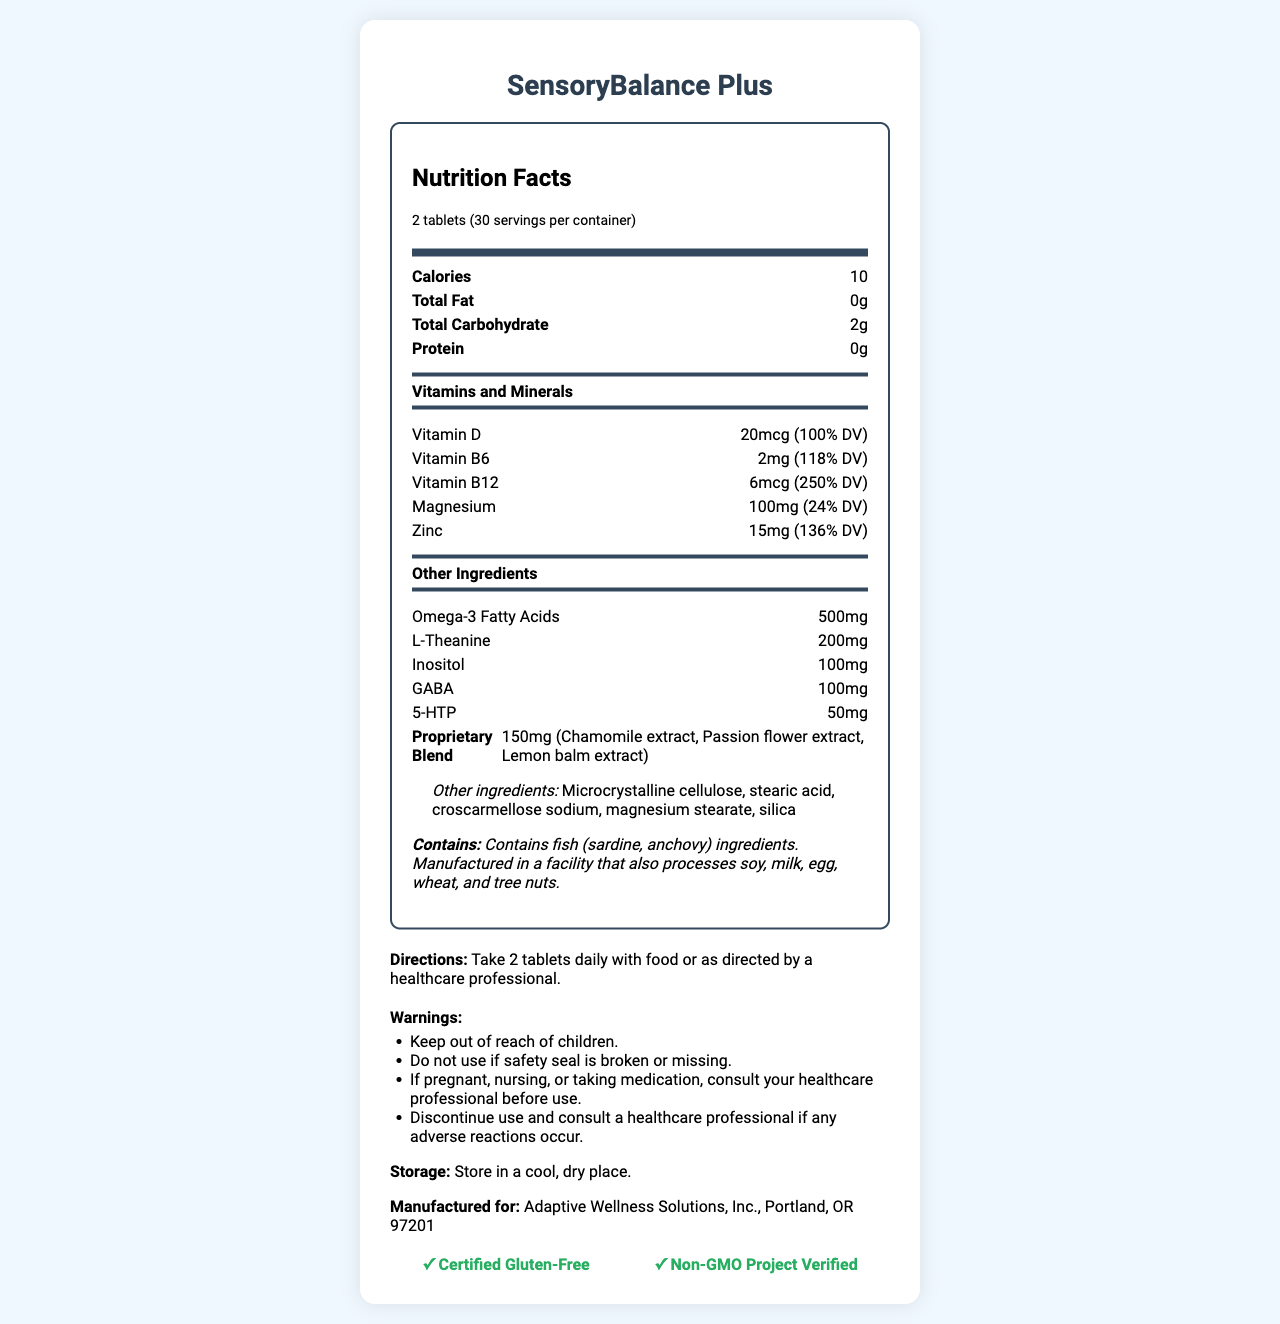what is the serving size for SensoryBalance Plus? The label clearly states that the serving size is 2 tablets.
Answer: 2 tablets how many servings are in one container? The document indicates that there are 30 servings per container.
Answer: 30 how many calories are in one serving? The section titled "Nutrition Facts" lists that each serving contains 10 calories.
Answer: 10 what percentage of the daily value (% DV) of Vitamin D does one serving provide? The nutrition label notes that there is 20mcg of Vitamin D, which is 100% of the daily value.
Answer: 100% what is the total amount of magnesium in one serving? In the "Vitamins and Minerals" section, it lists magnesium at 100mg per serving.
Answer: 100mg which ingredient listed under other ingredients might be of concern for individuals with fish allergies? A. Microcrystalline cellulose B. Stearic acid C. Croscarmellose sodium D. Omega-3 Fatty Acids The allergen information mentions that the product contains fish (sardine, anchovy) ingredients, which are associated with omega-3 fatty acids.
Answer: D. Omega-3 Fatty Acids which of the following vitamins is present in the highest percentage of the daily value? I. Vitamin D II. Vitamin B6 III. Vitamin B12 IV. Magnesium Vitamin B12 is listed at 250% DV, which is higher than the other vitamins mentioned.
Answer: III. Vitamin B12 is SensoryBalance Plus gluten-free? The document includes a certification for being "Certified Gluten-Free".
Answer: Yes what should you do if you are pregnant or nursing before taking this supplement? The warnings section advises consulting a healthcare professional if pregnant, nursing, or taking medication.
Answer: Consult your healthcare professional summarize the main purpose and key features of SensoryBalance Plus. The summary encapsulates the main purpose of the supplement, its target audience, an overview of its nutritional content, and important usage warnings.
Answer: SensoryBalance Plus is a dietary supplement designed for individuals with sensory processing disorders. It provides essential vitamins, minerals, and specialized ingredients like omega-3 fatty acids, L-Theanine, and GABA. The product is gluten-free, non-GMO, and contains fish ingredients with allergen warnings. Directions and several cautionary notes are provided for safe usage. what is the property of the proprietary blend? The label lists that the proprietary blend includes chamomile extract, passion flower extract, and lemon balm extract.
Answer: Contains Chamomile extract, Passion flower extract, Lemon balm extract who manufactures SensoryBalance Plus? The label specifies that the product is manufactured for Adaptive Wellness Solutions, Inc., located in Portland, OR 97201.
Answer: Adaptive Wellness Solutions, Inc., Portland, OR 97201 how much L-Theanine is in each serving of SensoryBalance Plus? The nutrition label states that each serving contains 200mg of L-Theanine.
Answer: 200mg cannot be answered: which healthcare professional should you consult before using SensoryBalance Plus? The document advises consulting a healthcare professional but does not specify any particular kind of healthcare professional.
Answer: Cannot be determined 